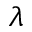<formula> <loc_0><loc_0><loc_500><loc_500>\lambda</formula> 